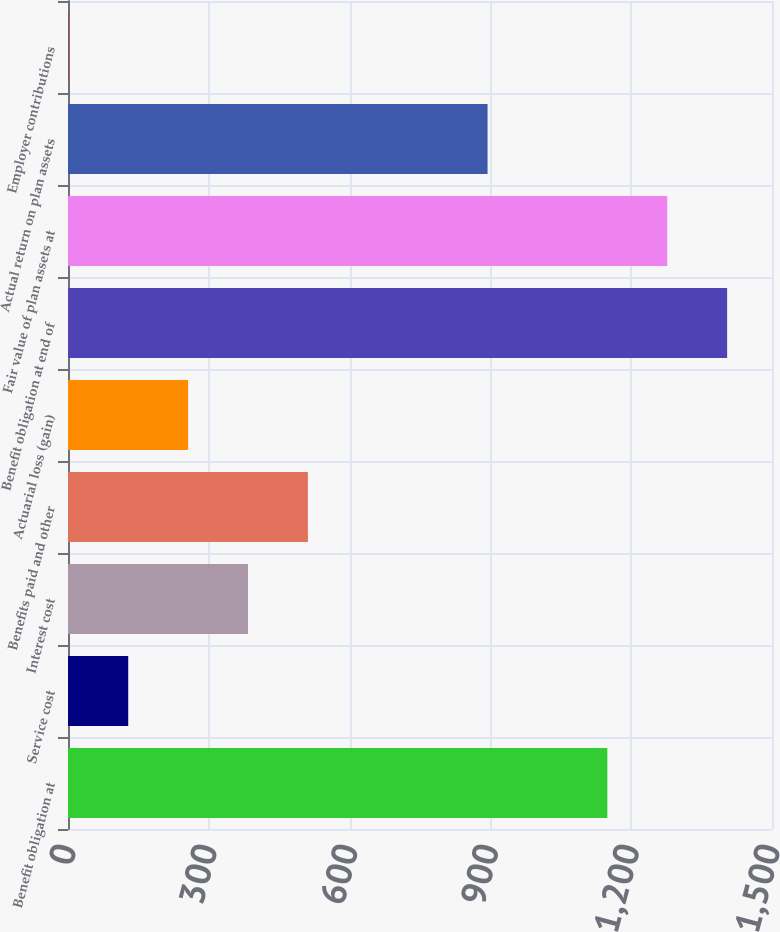Convert chart to OTSL. <chart><loc_0><loc_0><loc_500><loc_500><bar_chart><fcel>Benefit obligation at<fcel>Service cost<fcel>Interest cost<fcel>Benefits paid and other<fcel>Actuarial loss (gain)<fcel>Benefit obligation at end of<fcel>Fair value of plan assets at<fcel>Actual return on plan assets<fcel>Employer contributions<nl><fcel>1149.19<fcel>128.31<fcel>383.53<fcel>511.14<fcel>255.92<fcel>1404.41<fcel>1276.8<fcel>893.97<fcel>0.7<nl></chart> 